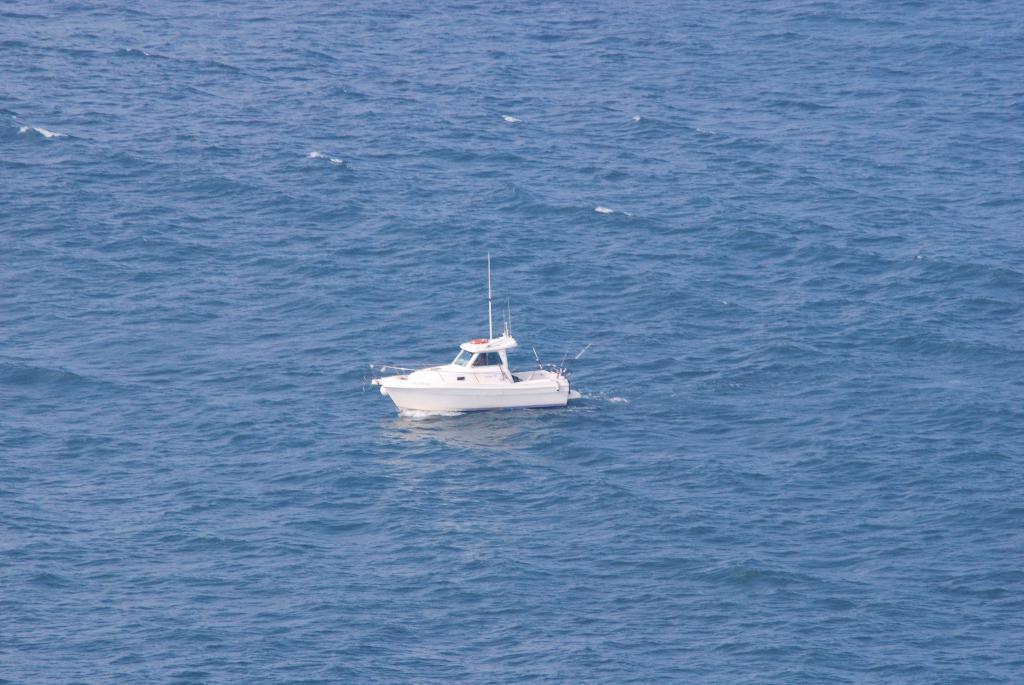Can you describe this image briefly? Above this water there is a white boat. 